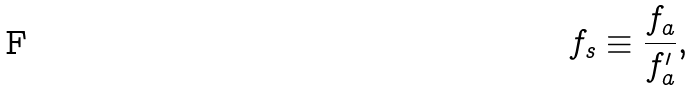Convert formula to latex. <formula><loc_0><loc_0><loc_500><loc_500>f _ { s } \equiv \frac { f _ { a } } { f ^ { \prime } _ { a } } ,</formula> 